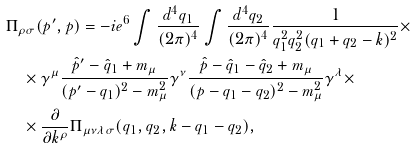Convert formula to latex. <formula><loc_0><loc_0><loc_500><loc_500>& \Pi _ { \rho \sigma } ( p ^ { \prime } , p ) = - i e ^ { 6 } \int \frac { d ^ { 4 } q _ { 1 } } { ( 2 \pi ) ^ { 4 } } \int \frac { d ^ { 4 } q _ { 2 } } { ( 2 \pi ) ^ { 4 } } \frac { 1 } { q _ { 1 } ^ { 2 } q _ { 2 } ^ { 2 } ( q _ { 1 } + q _ { 2 } - k ) ^ { 2 } } \times \\ & \quad \times \gamma ^ { \mu } \frac { \hat { p } ^ { \prime } - \hat { q } _ { 1 } + m _ { \mu } } { ( p ^ { \prime } - q _ { 1 } ) ^ { 2 } - m _ { \mu } ^ { 2 } } \gamma ^ { \nu } \frac { \hat { p } - \hat { q } _ { 1 } - \hat { q } _ { 2 } + m _ { \mu } } { ( p - q _ { 1 } - q _ { 2 } ) ^ { 2 } - m _ { \mu } ^ { 2 } } \gamma ^ { \lambda } \times \\ & \quad \times \frac { \partial } { \partial k ^ { \rho } } \Pi _ { \mu \nu \lambda \sigma } ( q _ { 1 } , q _ { 2 } , k - q _ { 1 } - q _ { 2 } ) ,</formula> 